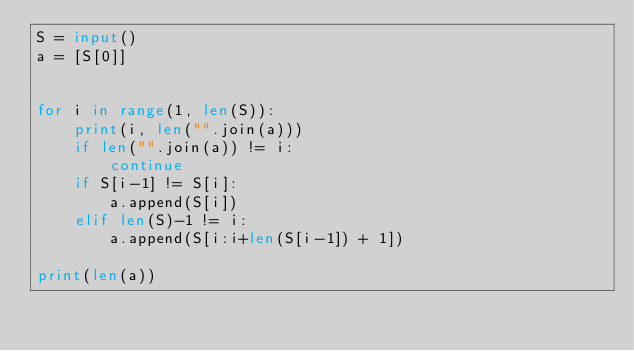<code> <loc_0><loc_0><loc_500><loc_500><_Python_>S = input()
a = [S[0]]


for i in range(1, len(S)):
    print(i, len("".join(a)))
    if len("".join(a)) != i:
        continue
    if S[i-1] != S[i]:
        a.append(S[i])
    elif len(S)-1 != i:
        a.append(S[i:i+len(S[i-1]) + 1])

print(len(a))
</code> 